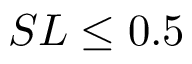<formula> <loc_0><loc_0><loc_500><loc_500>S L \leq 0 . 5</formula> 